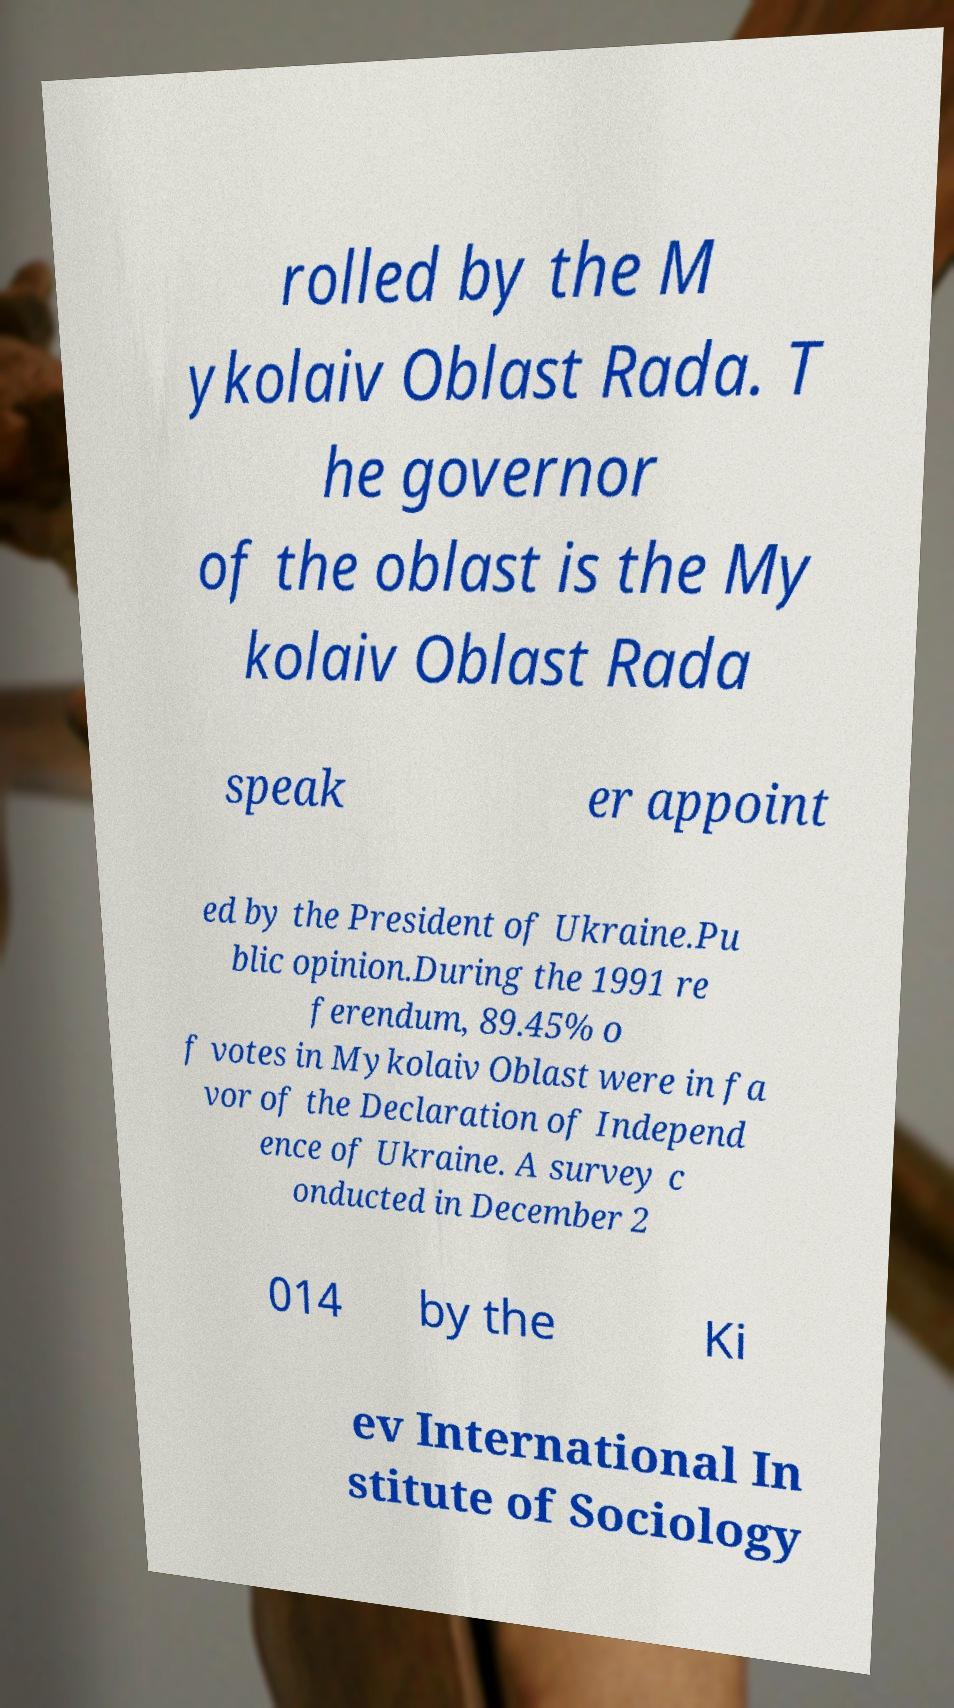For documentation purposes, I need the text within this image transcribed. Could you provide that? rolled by the M ykolaiv Oblast Rada. T he governor of the oblast is the My kolaiv Oblast Rada speak er appoint ed by the President of Ukraine.Pu blic opinion.During the 1991 re ferendum, 89.45% o f votes in Mykolaiv Oblast were in fa vor of the Declaration of Independ ence of Ukraine. A survey c onducted in December 2 014 by the Ki ev International In stitute of Sociology 